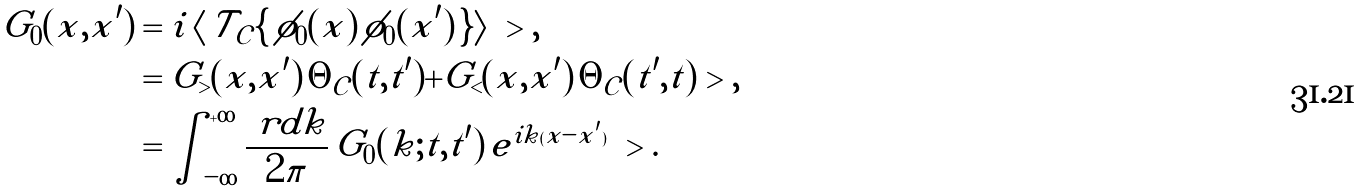<formula> <loc_0><loc_0><loc_500><loc_500>G _ { 0 } ( x , x ^ { \prime } ) & = i \, \langle \, \mathcal { T } _ { \mathcal { C } } \{ \, \phi _ { 0 } ( x ) \, \phi _ { 0 } ( x ^ { \prime } ) \, \} \rangle \ > , \\ & = G _ { > } ( x , x ^ { \prime } ) \, \Theta _ { \mathcal { C } } ( t , t ^ { \prime } ) + G _ { < } ( x , x ^ { \prime } ) \, \Theta _ { \mathcal { C } } ( t ^ { \prime } , t ) \ > , \\ & = \int _ { - \infty } ^ { + \infty } \frac { \ r d k } { 2 \pi } \, \tilde { G } _ { 0 } ( k ; t , t ^ { \prime } ) \, e ^ { i k ( x - x ^ { \prime } ) } \ > .</formula> 